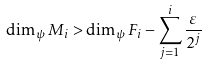Convert formula to latex. <formula><loc_0><loc_0><loc_500><loc_500>\dim _ { \psi } M _ { i } > \dim _ { \psi } F _ { i } - \sum _ { j = 1 } ^ { i } \frac { \varepsilon } { 2 ^ { j } }</formula> 